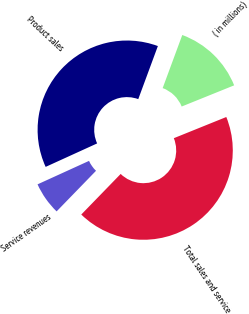<chart> <loc_0><loc_0><loc_500><loc_500><pie_chart><fcel>( in millions)<fcel>Product sales<fcel>Service revenues<fcel>Total sales and service<nl><fcel>13.26%<fcel>37.44%<fcel>5.93%<fcel>43.37%<nl></chart> 